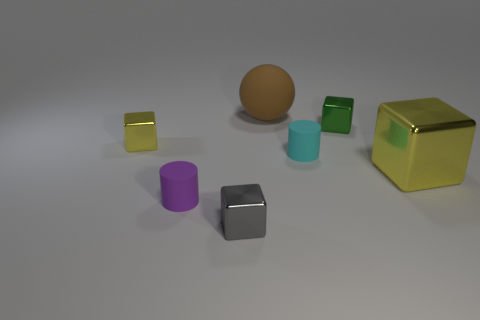What color is the small metal block that is behind the metal block that is to the left of the purple object?
Your answer should be compact. Green. What is the yellow block that is on the left side of the tiny metallic block that is in front of the tiny purple cylinder that is to the left of the big sphere made of?
Offer a terse response. Metal. There is a cylinder behind the purple matte cylinder; is it the same size as the large metallic object?
Offer a terse response. No. What is the yellow cube that is on the left side of the large yellow metallic cube made of?
Make the answer very short. Metal. Are there more small purple matte things than rubber cubes?
Provide a short and direct response. Yes. What number of objects are objects that are behind the big yellow metallic block or large metal cylinders?
Your answer should be compact. 4. What number of cyan objects are to the left of the cylinder that is on the right side of the tiny gray cube?
Your response must be concise. 0. There is a yellow block that is on the right side of the yellow shiny thing that is to the left of the tiny cyan cylinder that is in front of the brown matte object; what is its size?
Provide a succinct answer. Large. There is a tiny metallic cube that is on the left side of the small purple cylinder; is its color the same as the large shiny thing?
Your response must be concise. Yes. What size is the other yellow metallic thing that is the same shape as the small yellow metal thing?
Offer a very short reply. Large. 